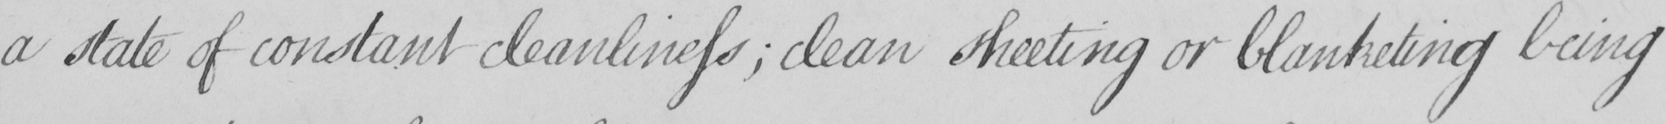What does this handwritten line say? a state of constant cleanliness  ; clean sheeting or blanketing being 